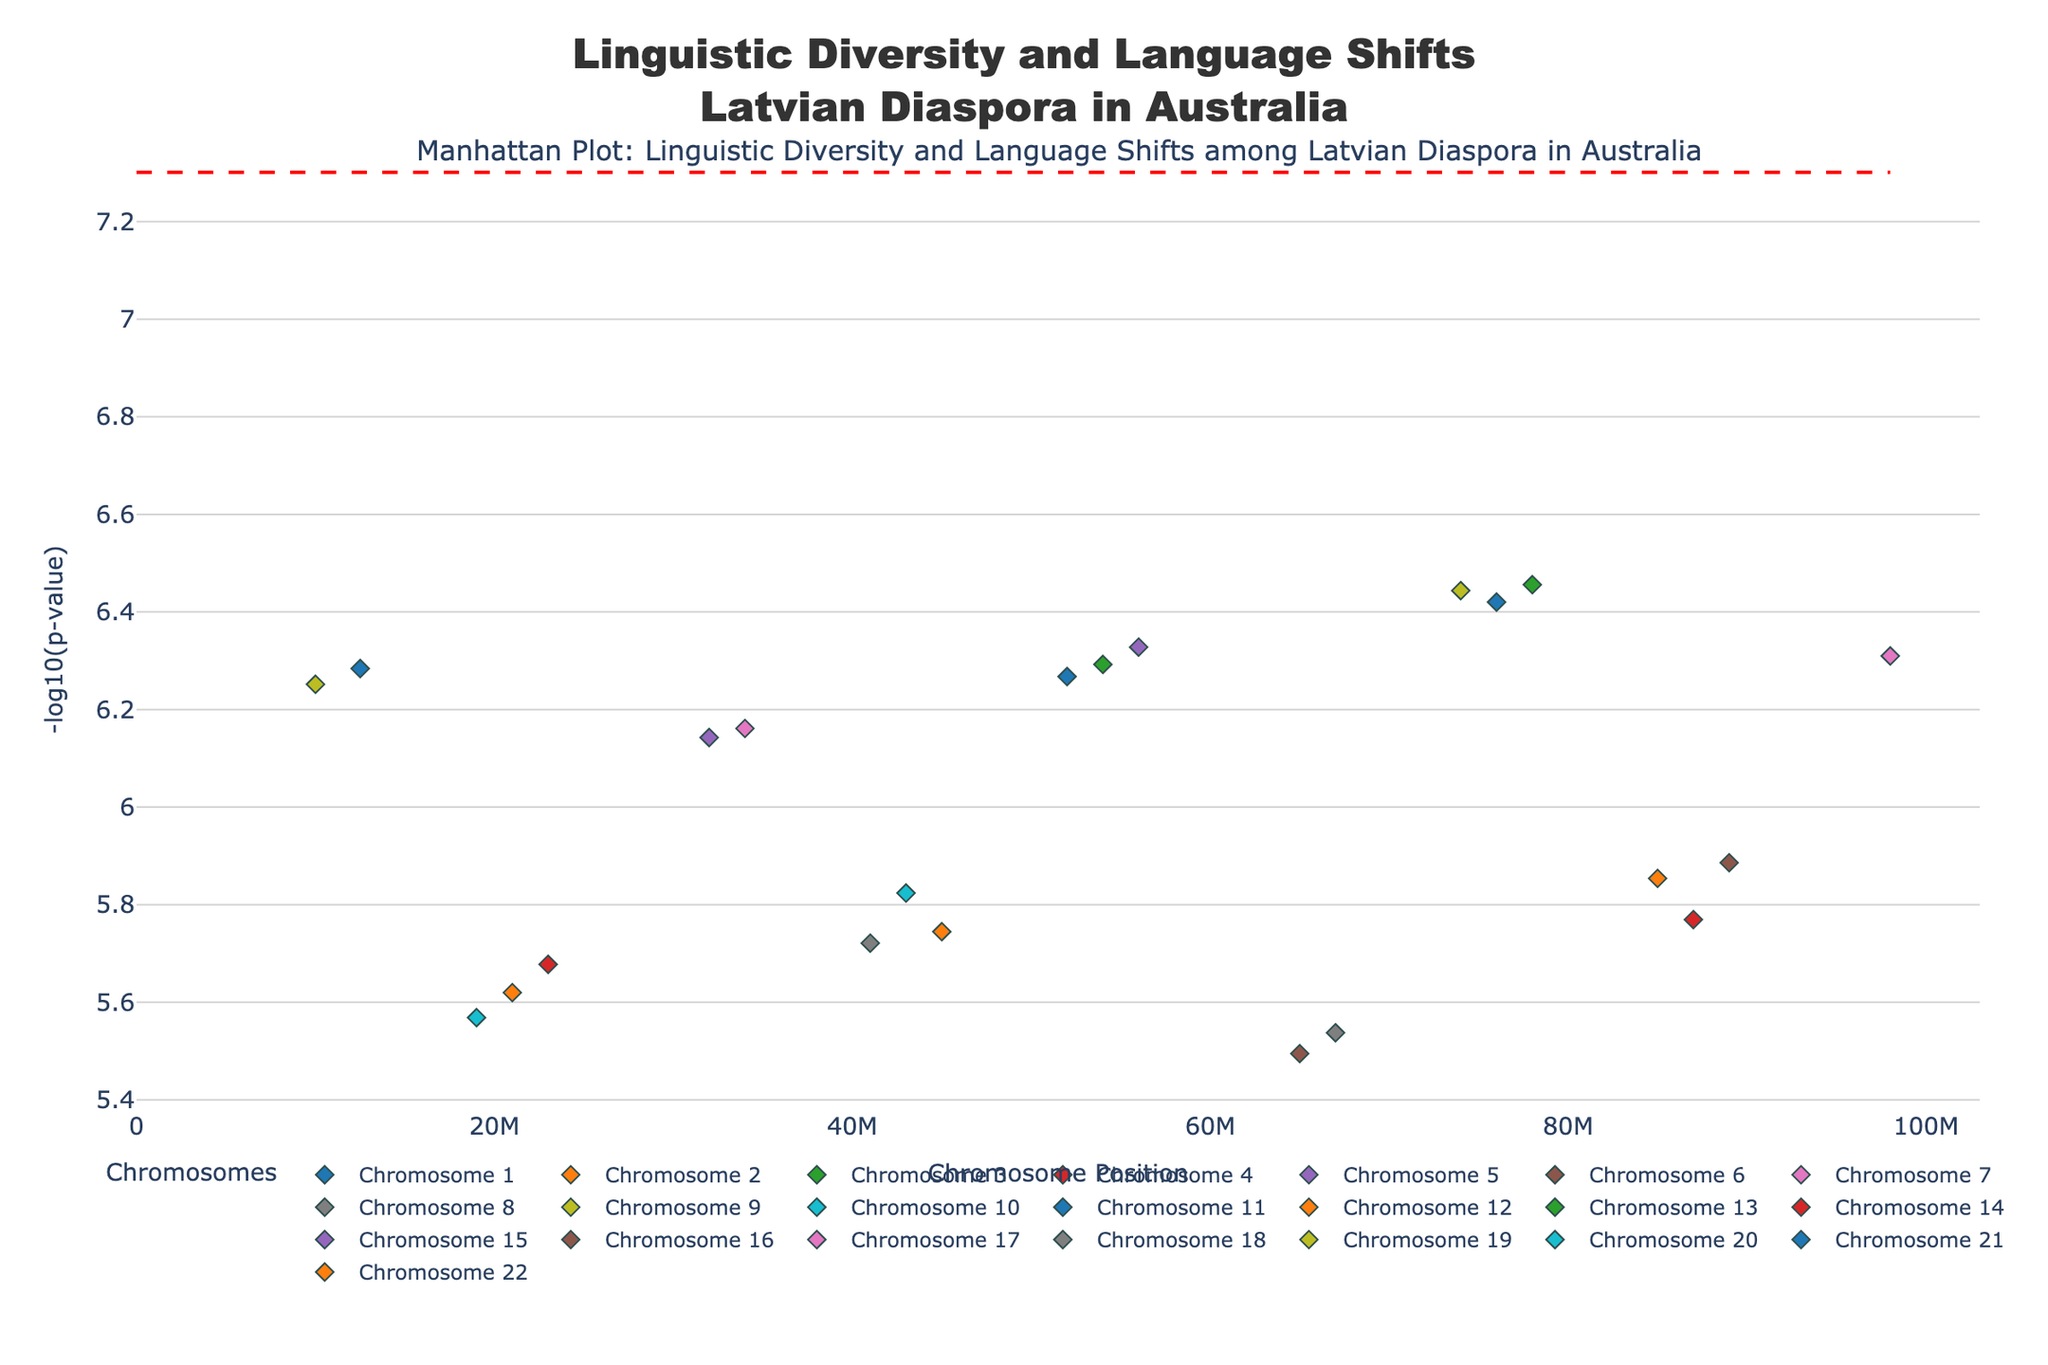What is the overall title of the figure? The figure title is located at the top center and it reads "Linguistic Diversity and Language Shifts Latvian Diaspora in Australia."
Answer: Linguistic Diversity and Language Shifts Latvian Diaspora in Australia How many chromosomes are represented in the plot? To find this, look at the legends that indicate the chromosomes. There are 22 different chromosomes mentioned.
Answer: 22 What color is used to denote the markers for Chromosome 3? Each chromosome is denoted by a different color. The markers for Chromosome 3 are shown in green.
Answer: green Which trait is associated with the SNP rs4567890 on Chromosome 3? Hovering over the markers for Chromosome 3 reveals that the trait associated with rs4567890 is "Bilingualism proficiency".
Answer: Bilingualism proficiency Is there a trait with its highest -log10(p-value) above 6? To determine this, look at the y-axis values. None of the points in the plot reach above a -log10(p-value) of 6.
Answer: No What is the threshold line set at in terms of -log10(p-value)? The red dashed horizontal line represents the threshold for significance. It's set at -log10(5e-8), which is approximately 7.3.
Answer: 7.3 Which chromosome contains the SNPs with the highest -log10(p-value)? Observing the y-axis values, Chromosome 1 has the SNP with the highest -log10(p-value) around 6.28.
Answer: Chromosome 1 How does the -log10(p-value) for "English language acquisition" compare to "Latvian cultural identity"? Locate the respective SNP markers for these traits. The -log10(p-values) for "English language acquisition" (Chromosome 2) and "Latvian cultural identity" (Chromosome 5) are approximately 5.74 and 6.33. "Latvian cultural identity" has a higher -log10(p-value).
Answer: Latvian cultural identity has a higher -log10(p-value) Which chromosomes have a -log10(p-value) above 6 for their associated SNPs? Check the y-axis values for each chromosome. Only Chromosome 1 and Chromosome 5 SNPs are above a -log10(p-value) of 6.
Answer: Chromosome 1, Chromosome 5 What is the range of chromosome positions on the x-axis? The x-axis represents the chromosome positions in base pairs. The positions range from 0 to just above 100,000,000 base pairs.
Answer: 0 to about 100,000,000 